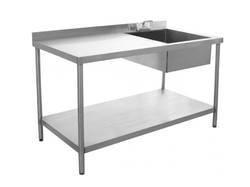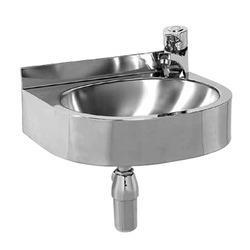The first image is the image on the left, the second image is the image on the right. Considering the images on both sides, is "An image shows a long sink unit with at least three faucets." valid? Answer yes or no. No. The first image is the image on the left, the second image is the image on the right. For the images displayed, is the sentence "Each sink featured has only one bowl, and one faucet." factually correct? Answer yes or no. Yes. 